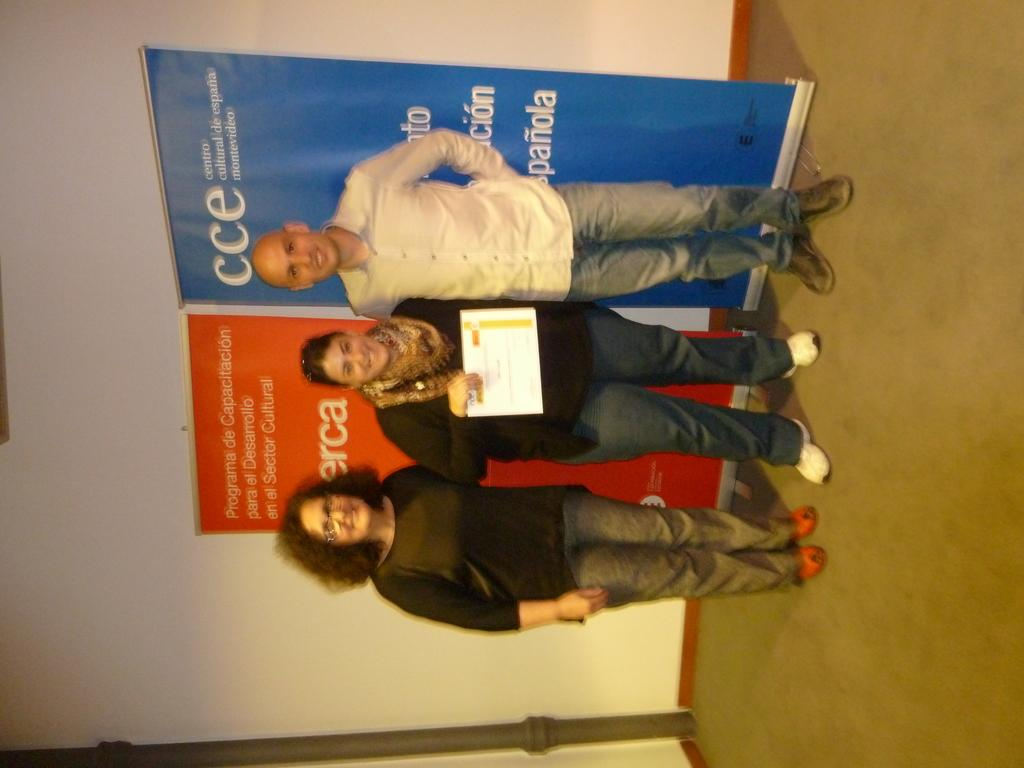How many people are in the image? There are two women and a man in the image, making a total of three individuals. What is the facial expression of the people in the image? All three individuals are smiling in the image. What is the middle woman holding? The middle woman is holding a paper. What can be seen in the background of the image? There are hoardings visible in the background of the image. What type of turkey can be seen kicking a soccer ball in the image? There is no turkey or soccer ball present in the image. What process is being depicted in the image? The image does not depict a process; it shows three people smiling and the middle woman holding a paper. 